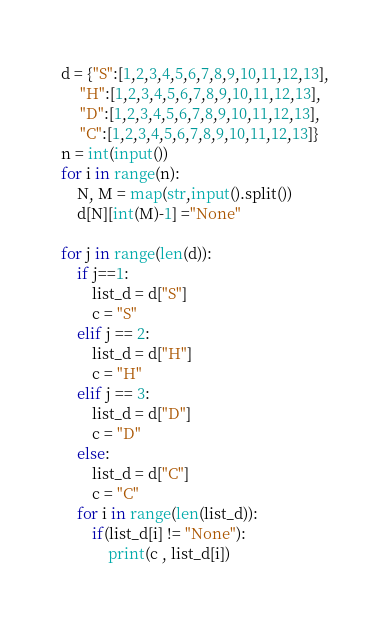Convert code to text. <code><loc_0><loc_0><loc_500><loc_500><_Python_>d = {"S":[1,2,3,4,5,6,7,8,9,10,11,12,13],
     "H":[1,2,3,4,5,6,7,8,9,10,11,12,13],
     "D":[1,2,3,4,5,6,7,8,9,10,11,12,13],
     "C":[1,2,3,4,5,6,7,8,9,10,11,12,13]}
n = int(input())
for i in range(n):
    N, M = map(str,input().split())
    d[N][int(M)-1] ="None"

for j in range(len(d)):
    if j==1:
        list_d = d["S"]
        c = "S"
    elif j == 2:
        list_d = d["H"]
        c = "H"
    elif j == 3:
        list_d = d["D"]
        c = "D"
    else:
        list_d = d["C"]
        c = "C"
    for i in range(len(list_d)):
        if(list_d[i] != "None"):
            print(c , list_d[i])
</code> 